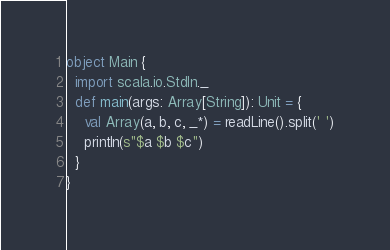<code> <loc_0><loc_0><loc_500><loc_500><_Scala_>object Main {
  import scala.io.StdIn._
  def main(args: Array[String]): Unit = {
    val Array(a, b, c, _*) = readLine().split(' ')
    println(s"$a $b $c")
  }
}
</code> 